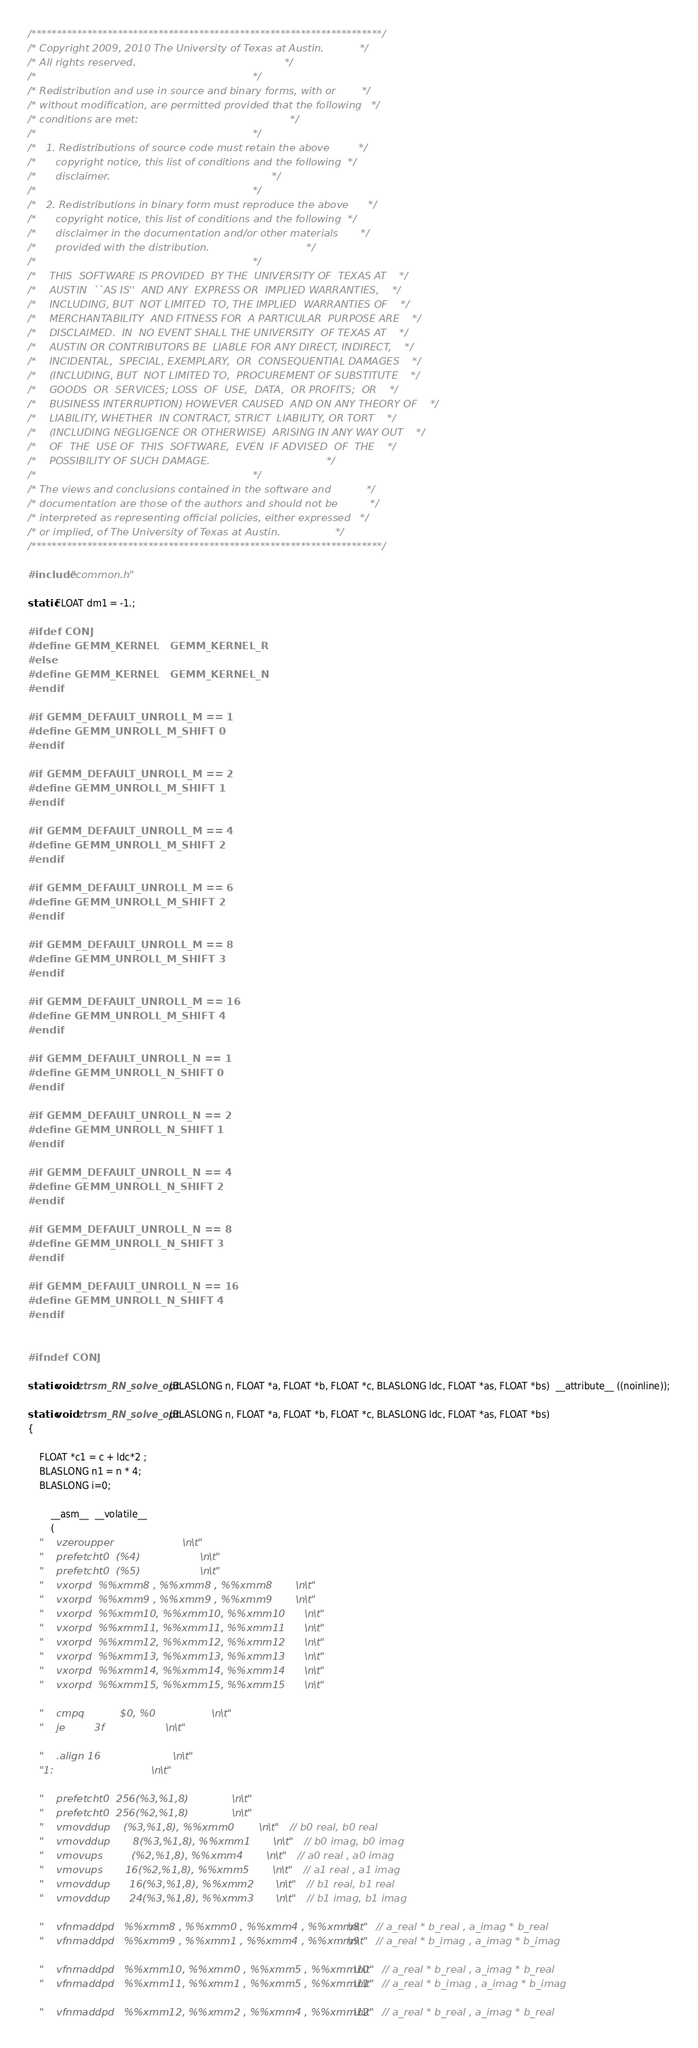Convert code to text. <code><loc_0><loc_0><loc_500><loc_500><_C_>/*********************************************************************/
/* Copyright 2009, 2010 The University of Texas at Austin.           */
/* All rights reserved.                                              */
/*                                                                   */
/* Redistribution and use in source and binary forms, with or        */
/* without modification, are permitted provided that the following   */
/* conditions are met:                                               */
/*                                                                   */
/*   1. Redistributions of source code must retain the above         */
/*      copyright notice, this list of conditions and the following  */
/*      disclaimer.                                                  */
/*                                                                   */
/*   2. Redistributions in binary form must reproduce the above      */
/*      copyright notice, this list of conditions and the following  */
/*      disclaimer in the documentation and/or other materials       */
/*      provided with the distribution.                              */
/*                                                                   */
/*    THIS  SOFTWARE IS PROVIDED  BY THE  UNIVERSITY OF  TEXAS AT    */
/*    AUSTIN  ``AS IS''  AND ANY  EXPRESS OR  IMPLIED WARRANTIES,    */
/*    INCLUDING, BUT  NOT LIMITED  TO, THE IMPLIED  WARRANTIES OF    */
/*    MERCHANTABILITY  AND FITNESS FOR  A PARTICULAR  PURPOSE ARE    */
/*    DISCLAIMED.  IN  NO EVENT SHALL THE UNIVERSITY  OF TEXAS AT    */
/*    AUSTIN OR CONTRIBUTORS BE  LIABLE FOR ANY DIRECT, INDIRECT,    */
/*    INCIDENTAL,  SPECIAL, EXEMPLARY,  OR  CONSEQUENTIAL DAMAGES    */
/*    (INCLUDING, BUT  NOT LIMITED TO,  PROCUREMENT OF SUBSTITUTE    */
/*    GOODS  OR  SERVICES; LOSS  OF  USE,  DATA,  OR PROFITS;  OR    */
/*    BUSINESS INTERRUPTION) HOWEVER CAUSED  AND ON ANY THEORY OF    */
/*    LIABILITY, WHETHER  IN CONTRACT, STRICT  LIABILITY, OR TORT    */
/*    (INCLUDING NEGLIGENCE OR OTHERWISE)  ARISING IN ANY WAY OUT    */
/*    OF  THE  USE OF  THIS  SOFTWARE,  EVEN  IF ADVISED  OF  THE    */
/*    POSSIBILITY OF SUCH DAMAGE.                                    */
/*                                                                   */
/* The views and conclusions contained in the software and           */
/* documentation are those of the authors and should not be          */
/* interpreted as representing official policies, either expressed   */
/* or implied, of The University of Texas at Austin.                 */
/*********************************************************************/

#include "common.h"

static FLOAT dm1 = -1.;

#ifdef CONJ
#define GEMM_KERNEL   GEMM_KERNEL_R
#else
#define GEMM_KERNEL   GEMM_KERNEL_N
#endif

#if GEMM_DEFAULT_UNROLL_M == 1
#define GEMM_UNROLL_M_SHIFT 0
#endif

#if GEMM_DEFAULT_UNROLL_M == 2
#define GEMM_UNROLL_M_SHIFT 1
#endif

#if GEMM_DEFAULT_UNROLL_M == 4
#define GEMM_UNROLL_M_SHIFT 2
#endif

#if GEMM_DEFAULT_UNROLL_M == 6
#define GEMM_UNROLL_M_SHIFT 2
#endif

#if GEMM_DEFAULT_UNROLL_M == 8
#define GEMM_UNROLL_M_SHIFT 3
#endif

#if GEMM_DEFAULT_UNROLL_M == 16
#define GEMM_UNROLL_M_SHIFT 4
#endif

#if GEMM_DEFAULT_UNROLL_N == 1
#define GEMM_UNROLL_N_SHIFT 0
#endif

#if GEMM_DEFAULT_UNROLL_N == 2
#define GEMM_UNROLL_N_SHIFT 1
#endif

#if GEMM_DEFAULT_UNROLL_N == 4
#define GEMM_UNROLL_N_SHIFT 2
#endif

#if GEMM_DEFAULT_UNROLL_N == 8
#define GEMM_UNROLL_N_SHIFT 3
#endif

#if GEMM_DEFAULT_UNROLL_N == 16
#define GEMM_UNROLL_N_SHIFT 4
#endif


#ifndef CONJ

static void ztrsm_RN_solve_opt(BLASLONG n, FLOAT *a, FLOAT *b, FLOAT *c, BLASLONG ldc, FLOAT *as, FLOAT *bs)  __attribute__ ((noinline));

static void ztrsm_RN_solve_opt(BLASLONG n, FLOAT *a, FLOAT *b, FLOAT *c, BLASLONG ldc, FLOAT *as, FLOAT *bs)
{

	FLOAT *c1 = c + ldc*2 ;
	BLASLONG n1 = n * 4;
	BLASLONG i=0;

        __asm__  __volatile__
        (
	"	vzeroupper							\n\t"
	"	prefetcht0	(%4)						\n\t"
	"	prefetcht0	(%5)						\n\t"
	"	vxorpd	%%xmm8 , %%xmm8 , %%xmm8				\n\t"
	"	vxorpd	%%xmm9 , %%xmm9 , %%xmm9				\n\t"
	"	vxorpd	%%xmm10, %%xmm10, %%xmm10				\n\t"
	"	vxorpd	%%xmm11, %%xmm11, %%xmm11				\n\t"
	"	vxorpd	%%xmm12, %%xmm12, %%xmm12				\n\t"
	"	vxorpd	%%xmm13, %%xmm13, %%xmm13				\n\t"
	"	vxorpd	%%xmm14, %%xmm14, %%xmm14				\n\t"
	"	vxorpd	%%xmm15, %%xmm15, %%xmm15				\n\t"

	"	cmpq	       $0, %0						\n\t"
	"	je	       3f						\n\t"

	"	.align 16							\n\t"
	"1:									\n\t"

	"	prefetcht0	256(%3,%1,8)					\n\t"
	"	prefetcht0	256(%2,%1,8)					\n\t"
	"	vmovddup	(%3,%1,8), %%xmm0				\n\t"	// b0 real, b0 real
	"	vmovddup       8(%3,%1,8), %%xmm1				\n\t"	// b0 imag, b0 imag
	"	vmovups         (%2,%1,8), %%xmm4				\n\t"	// a0 real , a0 imag
	"	vmovups       16(%2,%1,8), %%xmm5				\n\t"	// a1 real , a1 imag
	"	vmovddup      16(%3,%1,8), %%xmm2				\n\t"	// b1 real, b1 real
	"	vmovddup      24(%3,%1,8), %%xmm3				\n\t"	// b1 imag, b1 imag

	"	vfnmaddpd	%%xmm8 , %%xmm0 , %%xmm4 , %%xmm8		\n\t"   // a_real * b_real , a_imag * b_real
	"	vfnmaddpd	%%xmm9 , %%xmm1 , %%xmm4 , %%xmm9		\n\t"   // a_real * b_imag , a_imag * b_imag

	"	vfnmaddpd	%%xmm10, %%xmm0 , %%xmm5 , %%xmm10		\n\t"   // a_real * b_real , a_imag * b_real
	"	vfnmaddpd	%%xmm11, %%xmm1 , %%xmm5 , %%xmm11		\n\t"   // a_real * b_imag , a_imag * b_imag

	"	vfnmaddpd	%%xmm12, %%xmm2 , %%xmm4 , %%xmm12		\n\t"   // a_real * b_real , a_imag * b_real</code> 